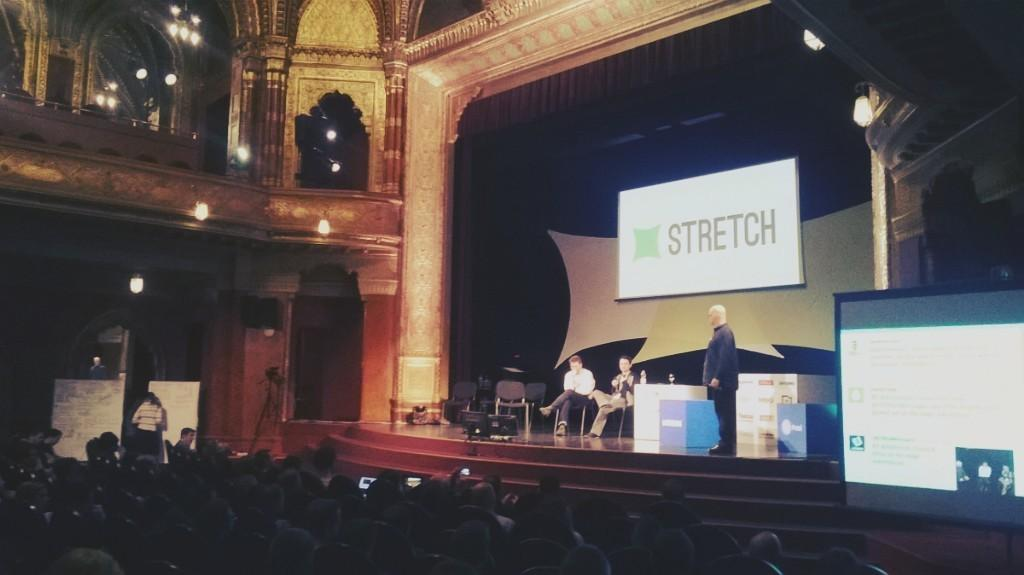Provide a one-sentence caption for the provided image. A projector displaying the word STRETCH to an audience of people on a stage. 